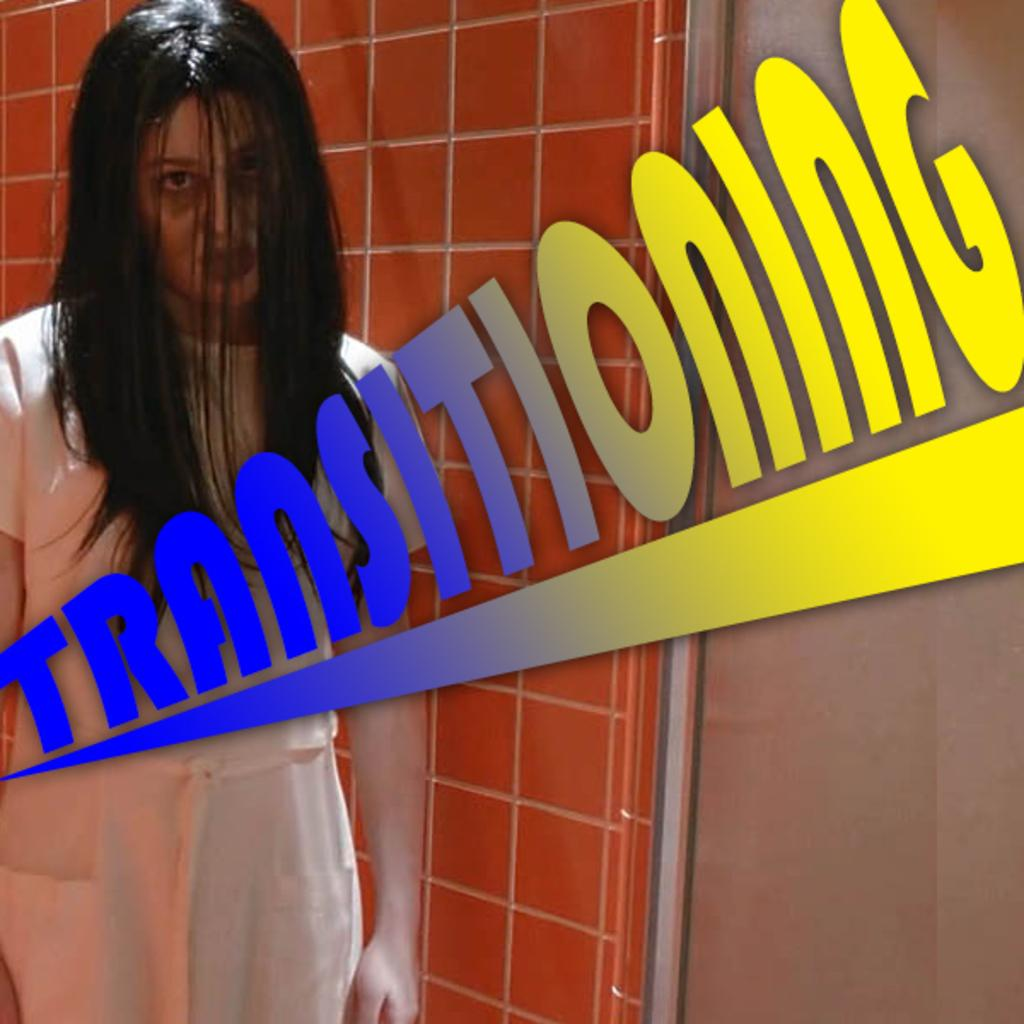<image>
Relay a brief, clear account of the picture shown. a picture of a zombie woman with the words TRANSITIONING in the front of it. 